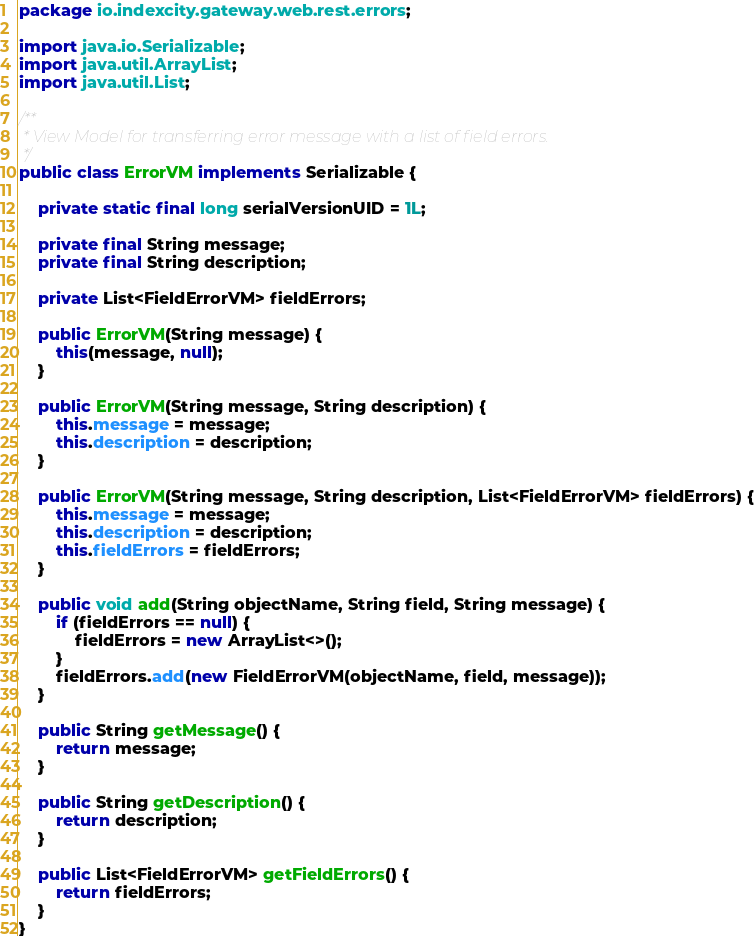Convert code to text. <code><loc_0><loc_0><loc_500><loc_500><_Java_>package io.indexcity.gateway.web.rest.errors;

import java.io.Serializable;
import java.util.ArrayList;
import java.util.List;

/**
 * View Model for transferring error message with a list of field errors.
 */
public class ErrorVM implements Serializable {

    private static final long serialVersionUID = 1L;

    private final String message;
    private final String description;

    private List<FieldErrorVM> fieldErrors;

    public ErrorVM(String message) {
        this(message, null);
    }

    public ErrorVM(String message, String description) {
        this.message = message;
        this.description = description;
    }

    public ErrorVM(String message, String description, List<FieldErrorVM> fieldErrors) {
        this.message = message;
        this.description = description;
        this.fieldErrors = fieldErrors;
    }

    public void add(String objectName, String field, String message) {
        if (fieldErrors == null) {
            fieldErrors = new ArrayList<>();
        }
        fieldErrors.add(new FieldErrorVM(objectName, field, message));
    }

    public String getMessage() {
        return message;
    }

    public String getDescription() {
        return description;
    }

    public List<FieldErrorVM> getFieldErrors() {
        return fieldErrors;
    }
}
</code> 